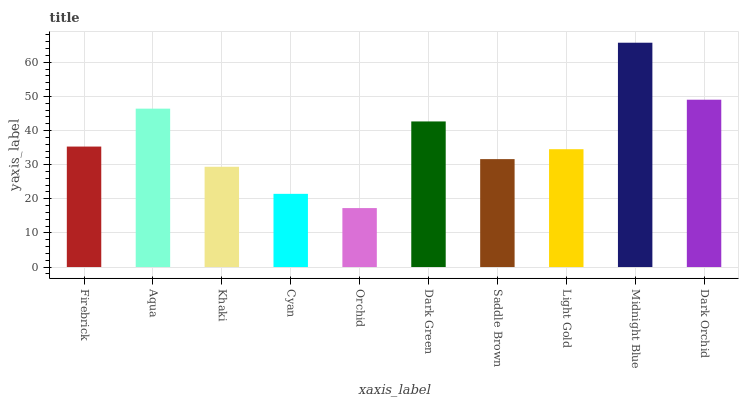Is Orchid the minimum?
Answer yes or no. Yes. Is Midnight Blue the maximum?
Answer yes or no. Yes. Is Aqua the minimum?
Answer yes or no. No. Is Aqua the maximum?
Answer yes or no. No. Is Aqua greater than Firebrick?
Answer yes or no. Yes. Is Firebrick less than Aqua?
Answer yes or no. Yes. Is Firebrick greater than Aqua?
Answer yes or no. No. Is Aqua less than Firebrick?
Answer yes or no. No. Is Firebrick the high median?
Answer yes or no. Yes. Is Light Gold the low median?
Answer yes or no. Yes. Is Dark Green the high median?
Answer yes or no. No. Is Cyan the low median?
Answer yes or no. No. 